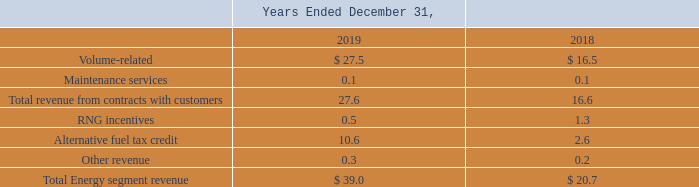ANG's revenues are principally derived from sales of compressed natural gas. ANG recognizes revenue from the sale of natural gas fuel primarily at the time the fuel is dispensed.
In December 2019, the U.S. Congress passed an alternative fuel tax credit ("AFTC") which will continue to support the use of natural gas. The AFTC is retroactive beginning January 2018 and extends through 2020.
The legislation extends the $0.50 per gallon fuel credit/payment for the use of natural gas as a transportation fuel, and the Alternative Fuel Vehicle Refueling Property Credit, which extends the 30 percent/$30,000 investment tax credit for alternative vehicle refueling property. Net revenue after customer rebates for such credits recognized in 2019 was $10.6 million.
As a result of the Bipartisan Budget Act of 2018, signed into law on February 9, 2018, all AFTC revenue for vehicle fuel ANG sold in 2017 was collected in the second quarter of 2018. Net revenue after customer rebates for such credits recognized in 2018 was $2.6 million.
Disaggregation of Revenues The following table disaggregates ANG's revenue by type (in millions):
When did the U.S. Congress pass the alternative fuel tax credit ("AFTC")? December 2019. What was the net revenue after customer rebates for credits recognized in 2019? $10.6 million. What was the different count of revenue generated by company? 5. What was the increase / (decrease) in the volume-related revenue from 2018 to 2019?
Answer scale should be: million. 27.5 - 16.5
Answer: 11. What was the average maintenance services?
Answer scale should be: million. (0.1 + 0.1) / 2
Answer: 0.1. What is the percentage increase / (decrease) in the total revenue from contracts with customers from 2018 to 2019?
Answer scale should be: percent. 27.6 / 16.6 - 1
Answer: 66.27. 